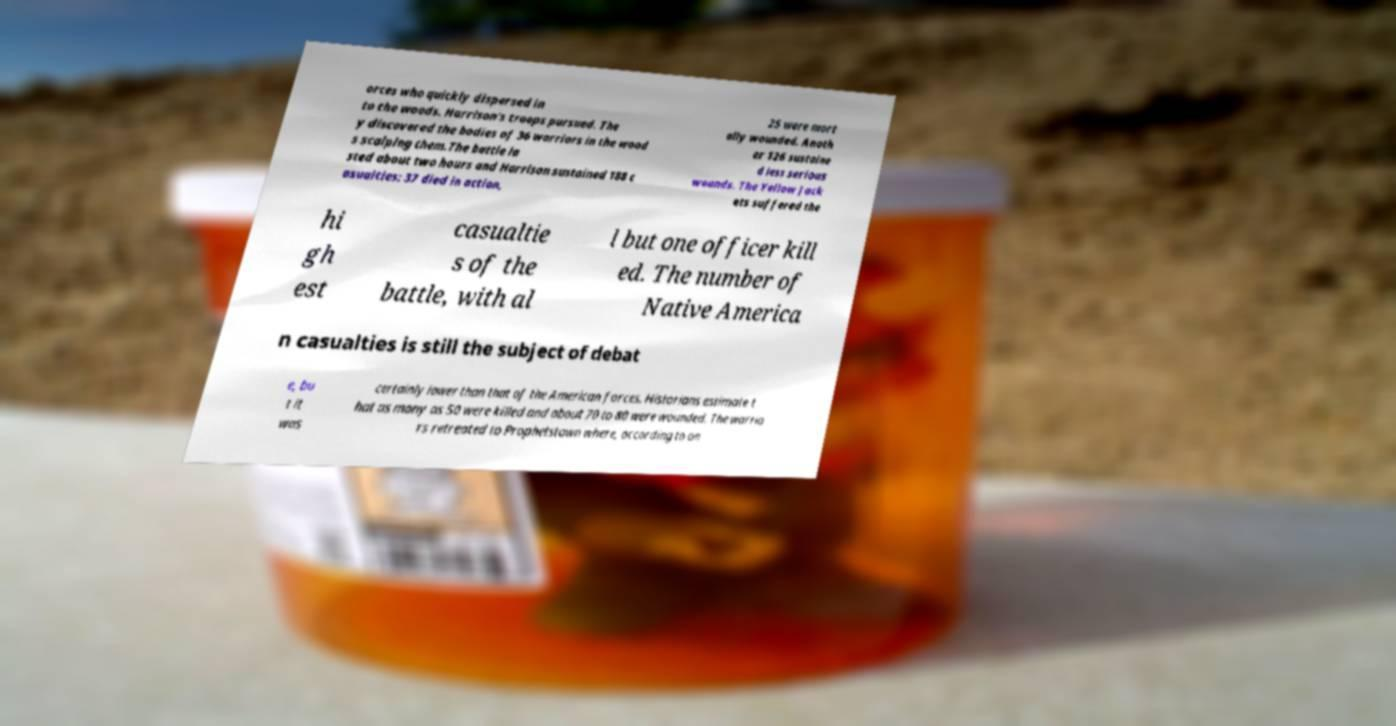Can you read and provide the text displayed in the image?This photo seems to have some interesting text. Can you extract and type it out for me? orces who quickly dispersed in to the woods. Harrison's troops pursued. The y discovered the bodies of 36 warriors in the wood s scalping them.The battle la sted about two hours and Harrison sustained 188 c asualties: 37 died in action, 25 were mort ally wounded. Anoth er 126 sustaine d less serious wounds. The Yellow Jack ets suffered the hi gh est casualtie s of the battle, with al l but one officer kill ed. The number of Native America n casualties is still the subject of debat e, bu t it was certainly lower than that of the American forces. Historians estimate t hat as many as 50 were killed and about 70 to 80 were wounded. The warrio rs retreated to Prophetstown where, according to on 